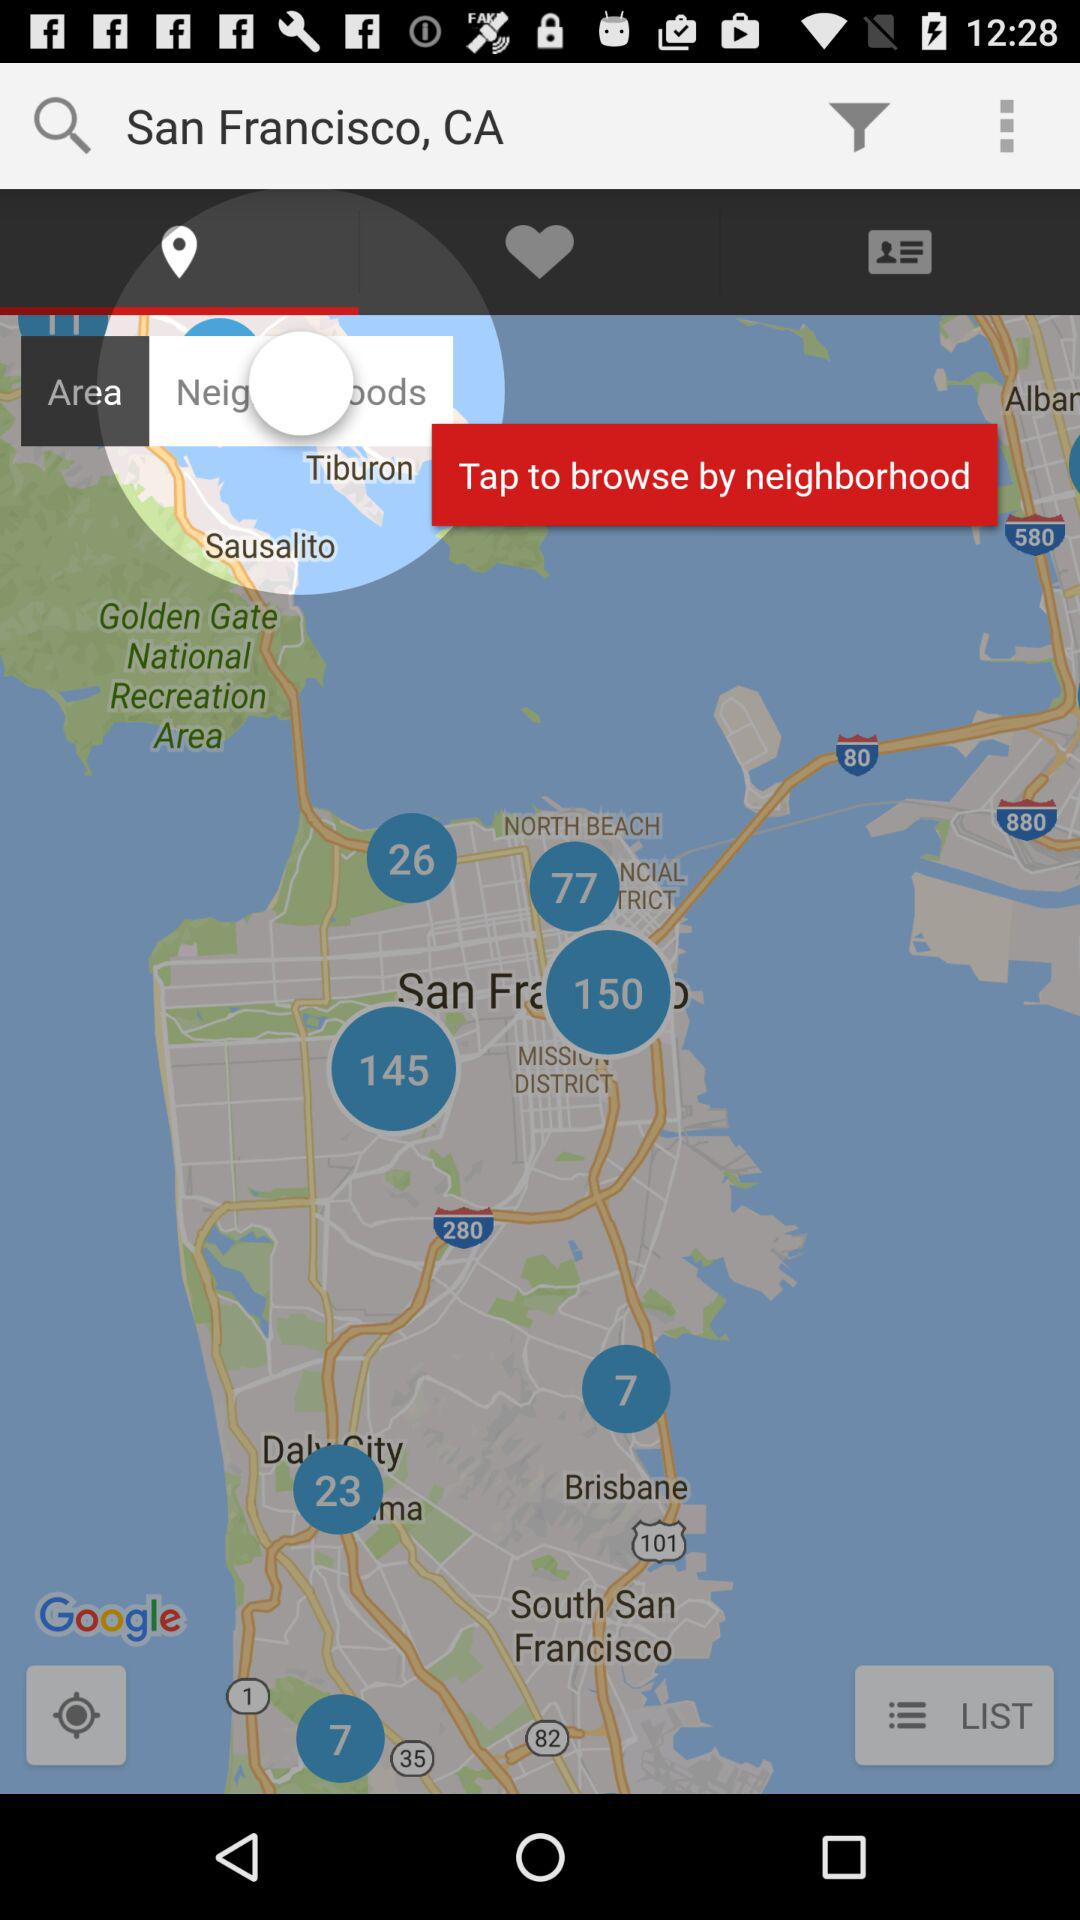What is the current location? The current location is San Francisco, CA. 